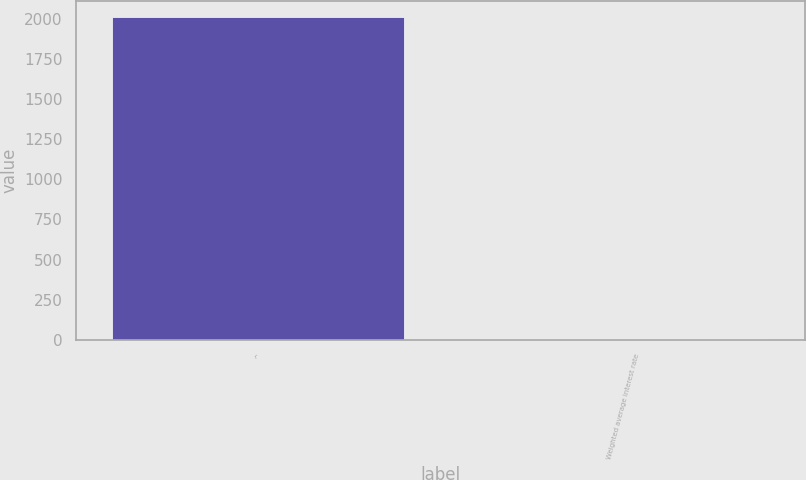Convert chart to OTSL. <chart><loc_0><loc_0><loc_500><loc_500><bar_chart><fcel>^<fcel>Weighted average interest rate<nl><fcel>2009<fcel>5.61<nl></chart> 